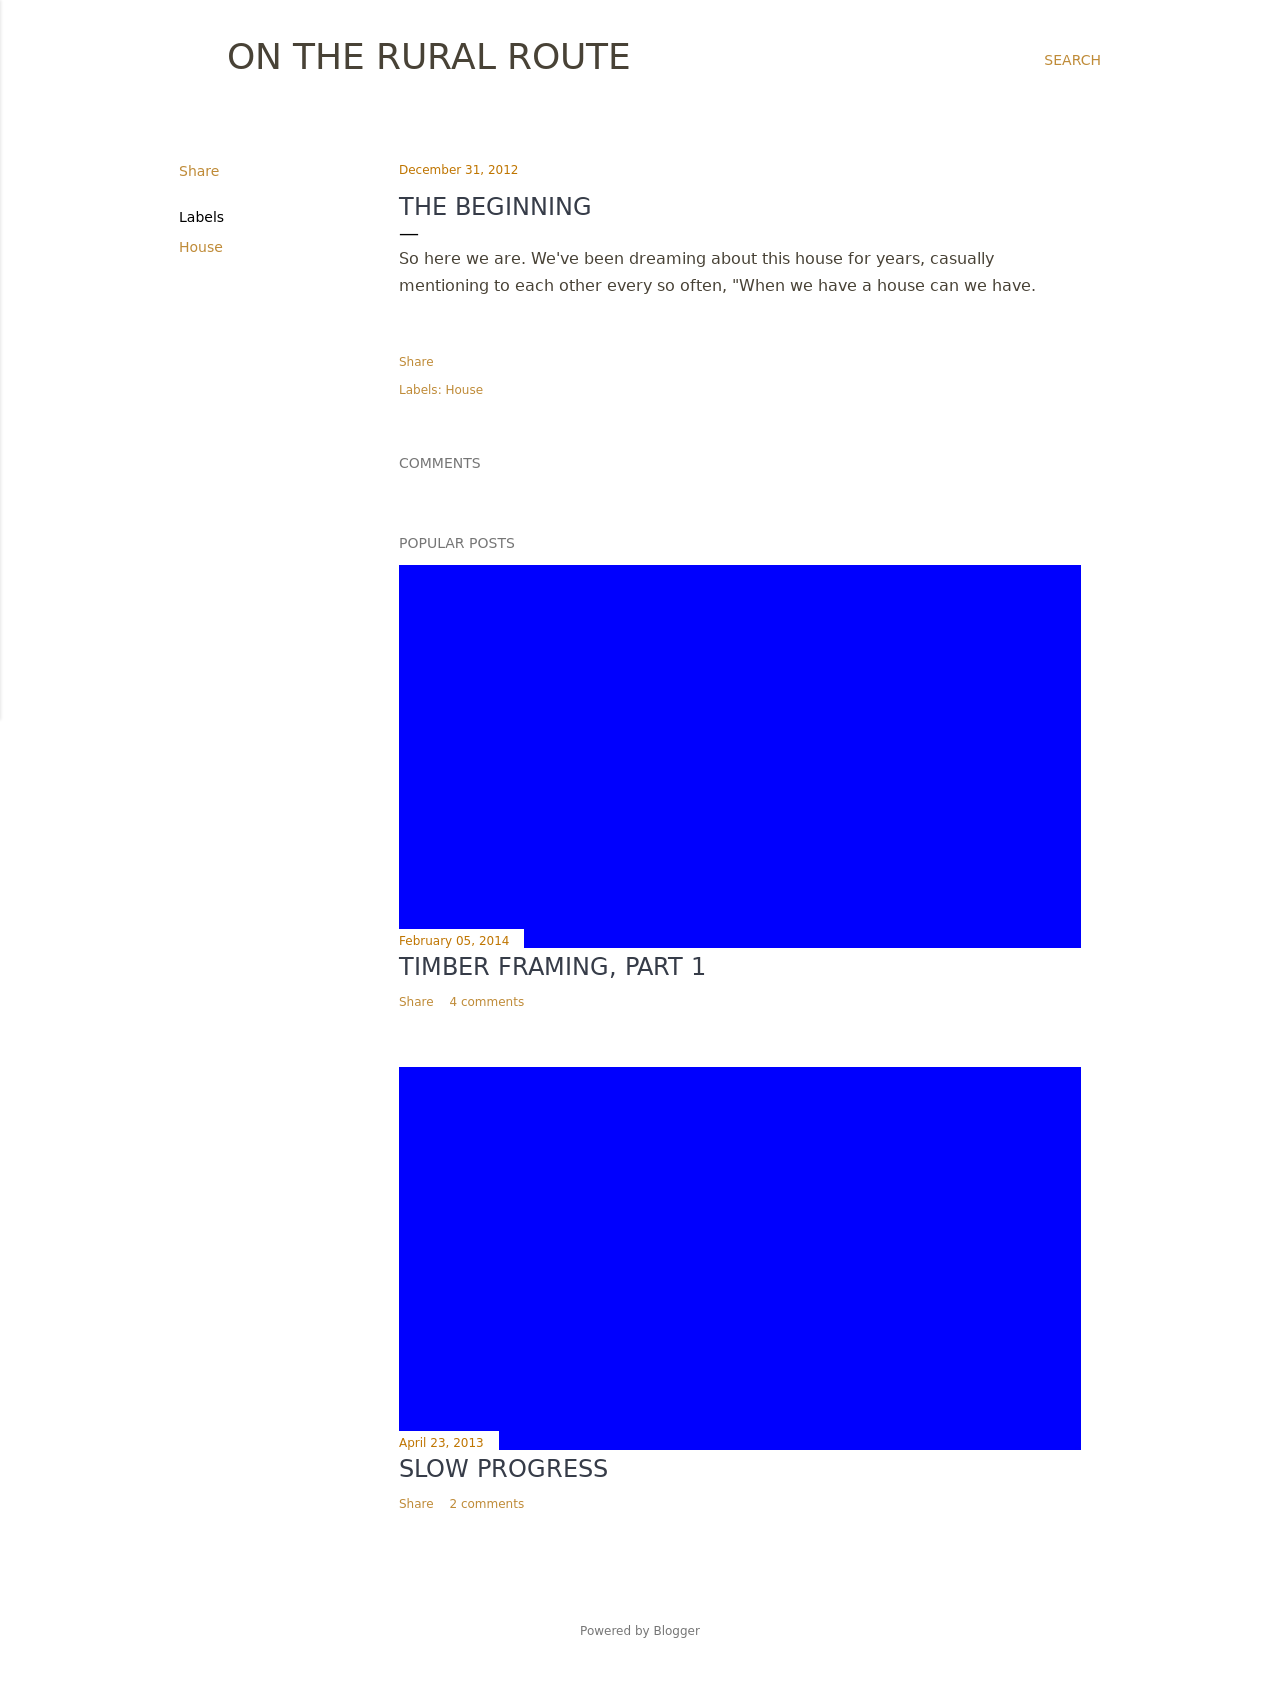Can you suggest a color scheme that matches the minimal style of the blog shown in this image? For a minimalistic style as displayed, consider using a monochromatic color scheme that includes shades of grey or a combination of black and white. This will keep the look clean while offering enough contrast. Accent colors should be subtle, like soft blues or muted greens, to add a hint of personality without overwhelming the aesthetic. 